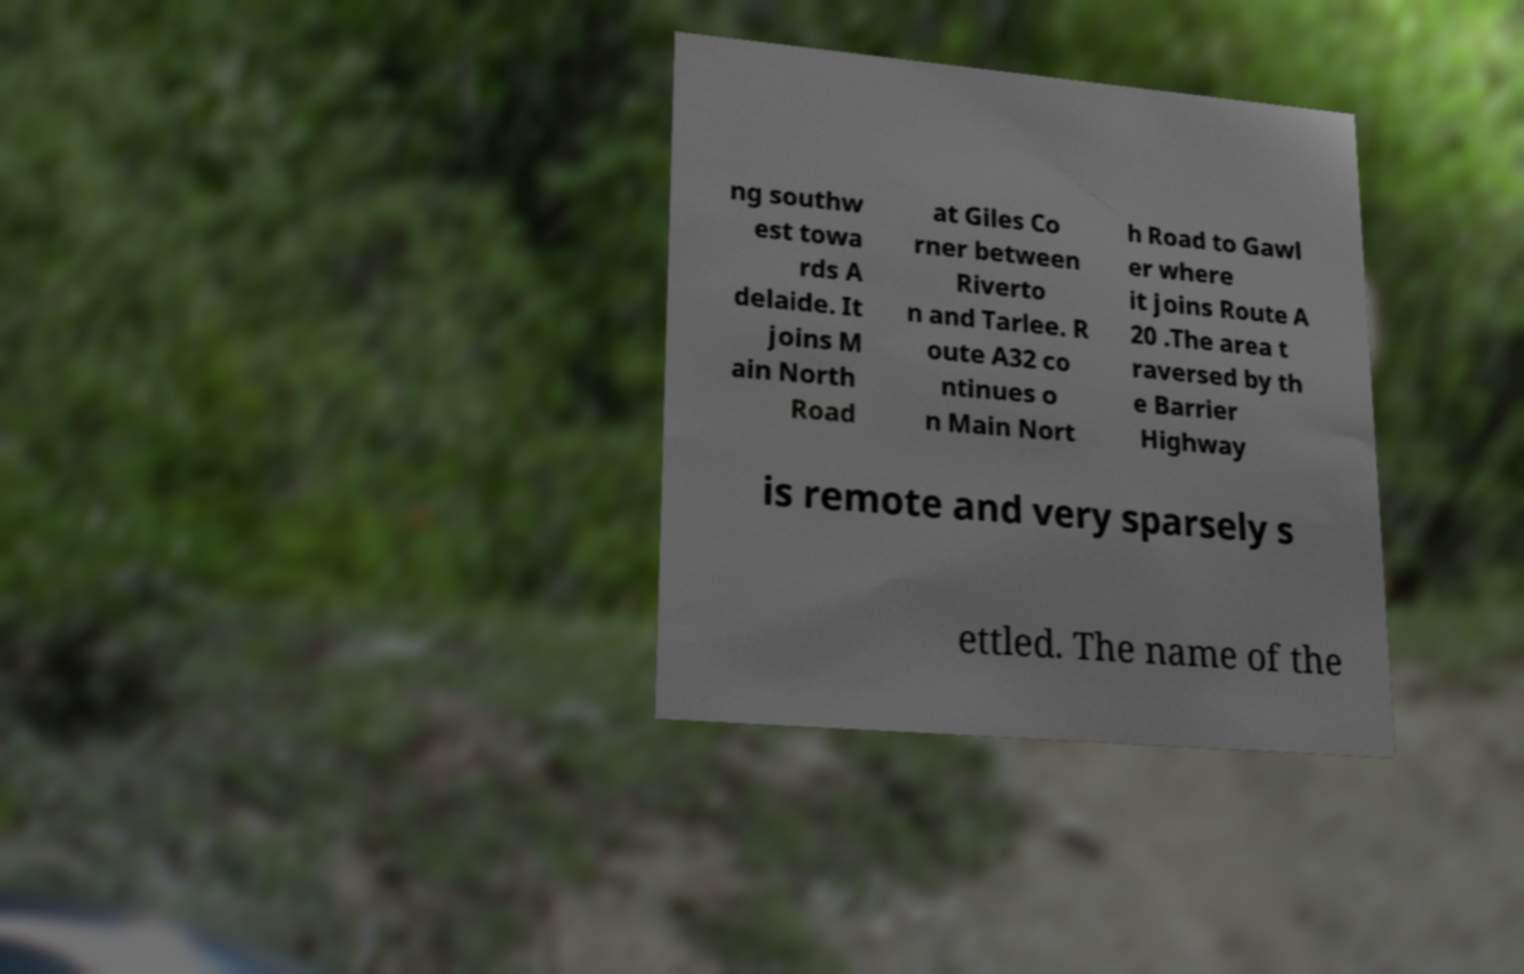For documentation purposes, I need the text within this image transcribed. Could you provide that? ng southw est towa rds A delaide. It joins M ain North Road at Giles Co rner between Riverto n and Tarlee. R oute A32 co ntinues o n Main Nort h Road to Gawl er where it joins Route A 20 .The area t raversed by th e Barrier Highway is remote and very sparsely s ettled. The name of the 